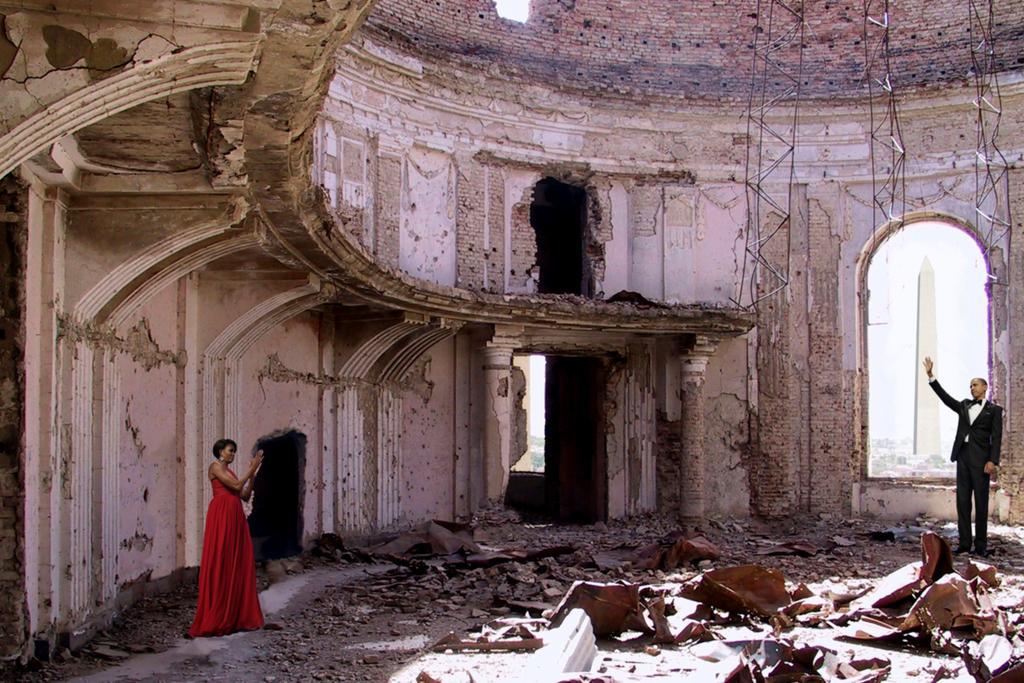Please provide a concise description of this image. In the center of the image there is a broken building. At the left side of the image there is a lady standing in a red dress. At the right side of the image there is a man standing wearing a black color suit. 